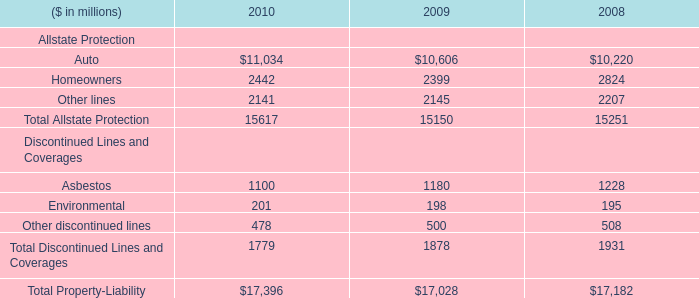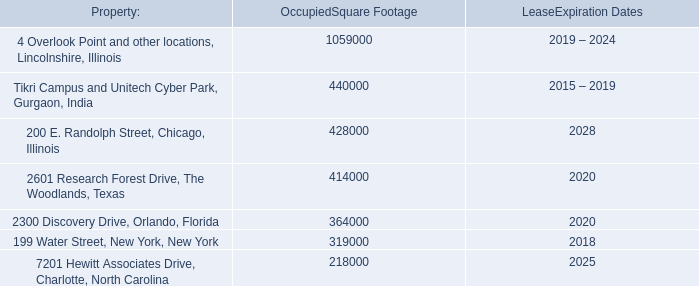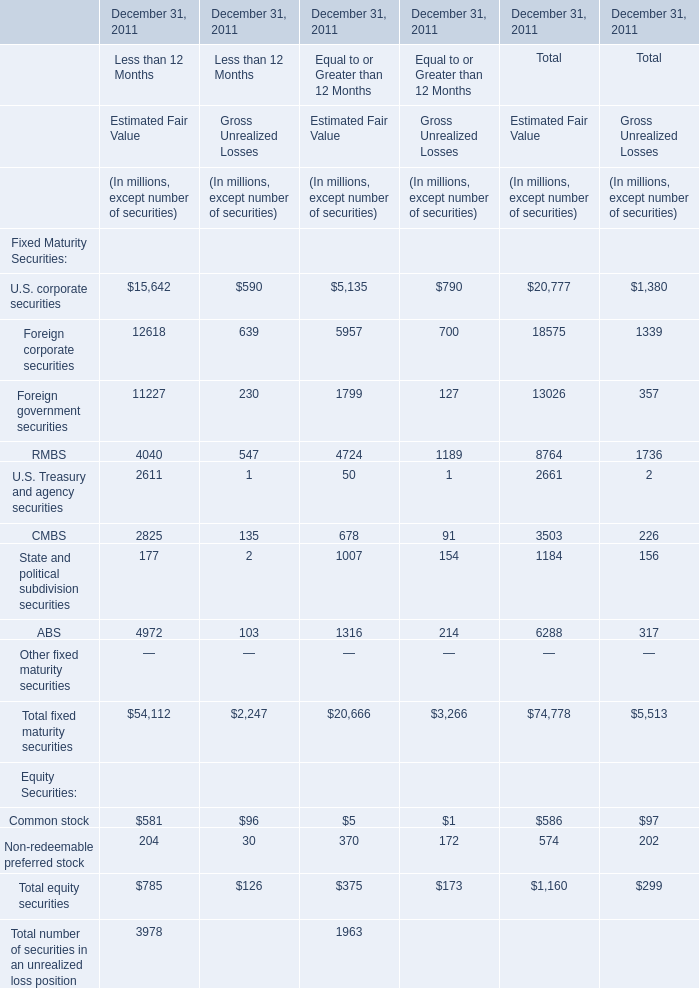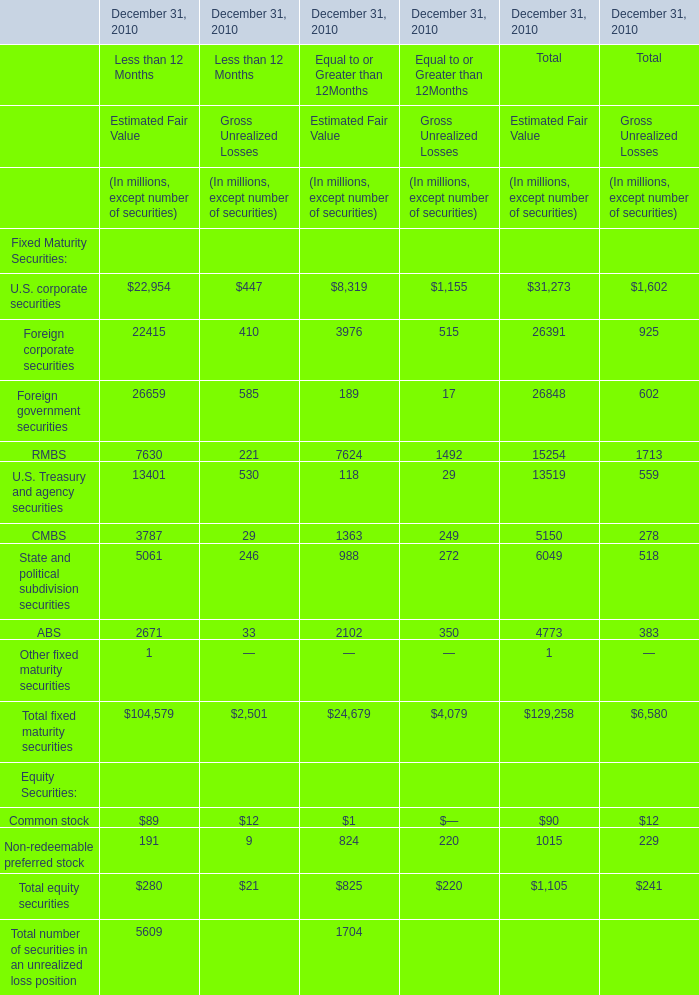What was the average value of the State and political subdivision securities in the year where Total equity securities is positive? (in million) 
Computations: ((1184 + 156) / 4)
Answer: 335.0. 